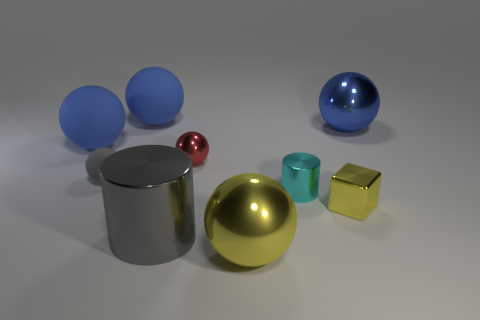Subtract all gray cylinders. How many blue balls are left? 3 Subtract all yellow balls. How many balls are left? 5 Subtract all big yellow shiny balls. How many balls are left? 5 Subtract all red balls. Subtract all yellow cylinders. How many balls are left? 5 Subtract all cubes. How many objects are left? 8 Subtract all shiny cubes. Subtract all big yellow metal spheres. How many objects are left? 7 Add 7 small gray objects. How many small gray objects are left? 8 Add 5 big brown metal balls. How many big brown metal balls exist? 5 Subtract 0 purple spheres. How many objects are left? 9 